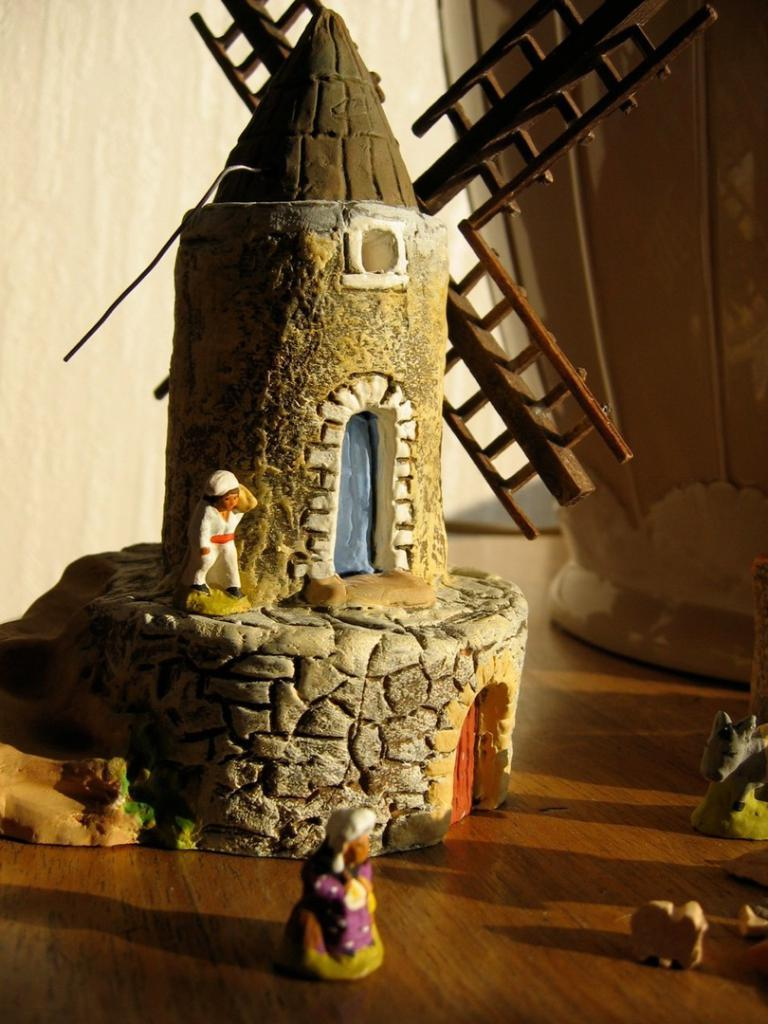What type of toy is in the image? There is a toy house in the image. What features does the toy house have? The toy house has doors. Are there any other toys present in the image? Yes, there are toy people and toy animals in the image. On what surface are the toys placed? The toys are placed on a wooden surface. What can be seen in the background of the image? There is a wall and a pot in the background of the image. What type of locket is hanging from the toy house in the image? There is no locket present in the image; it features a toy house, toy people, toy animals, and other background elements. 